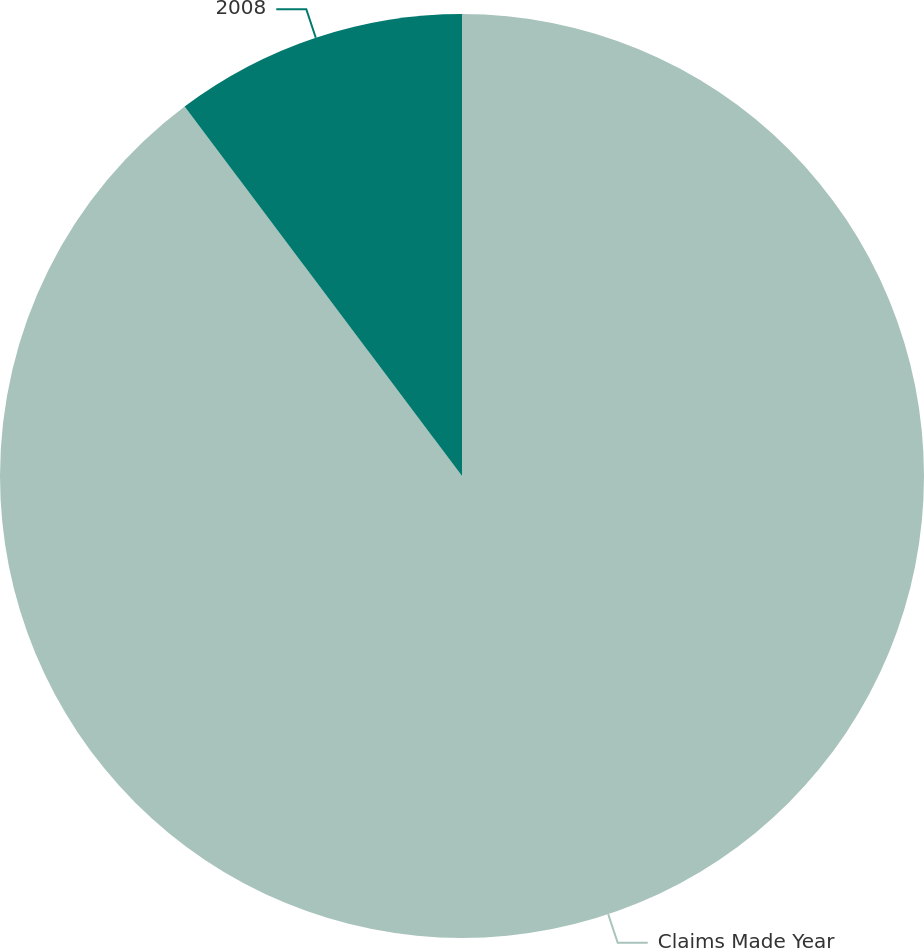Convert chart to OTSL. <chart><loc_0><loc_0><loc_500><loc_500><pie_chart><fcel>Claims Made Year<fcel>2008<nl><fcel>89.75%<fcel>10.25%<nl></chart> 